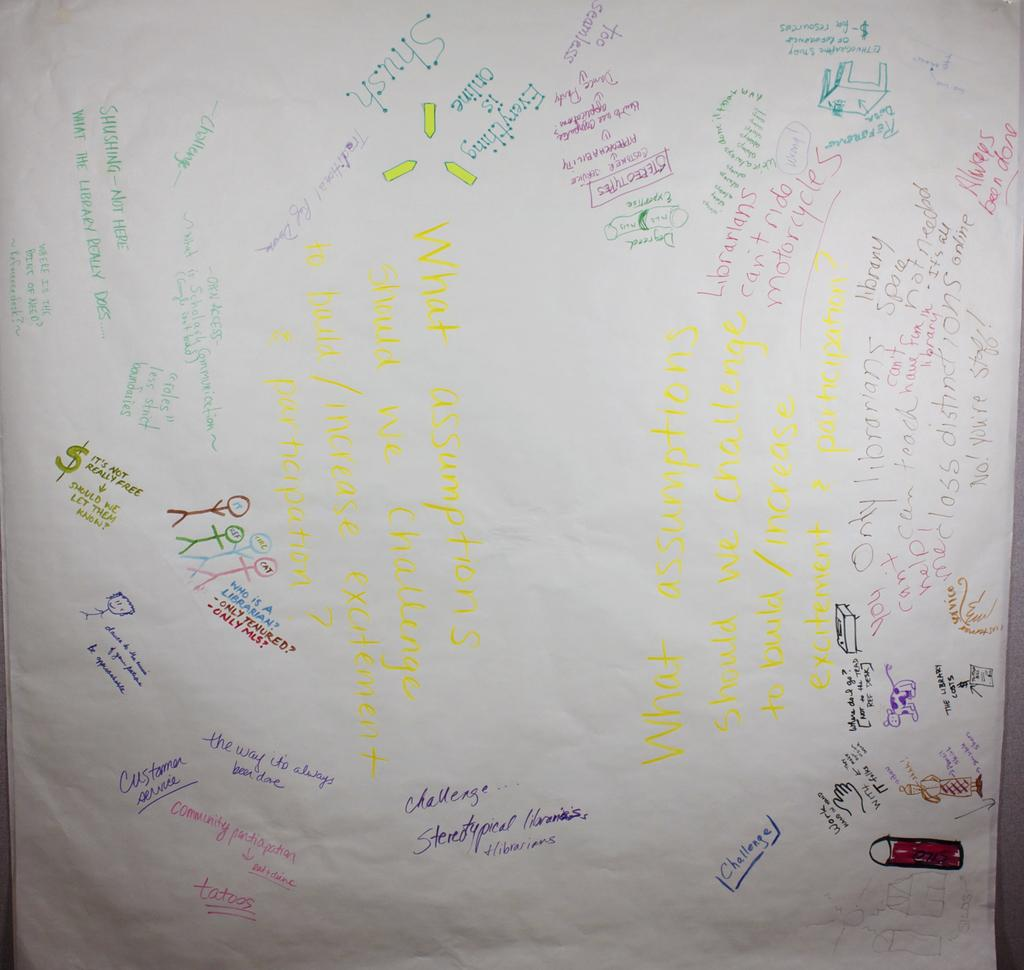What is the main object in the image? There is a white color sheet in the image. What is written or printed on the sheet? There is text on the sheet. Can you describe the text on the sheet? The text is in multiple colors. What type of cake is being divided among the people in the image? There is no cake or people present in the image; it only features a white color sheet with text in multiple colors. 